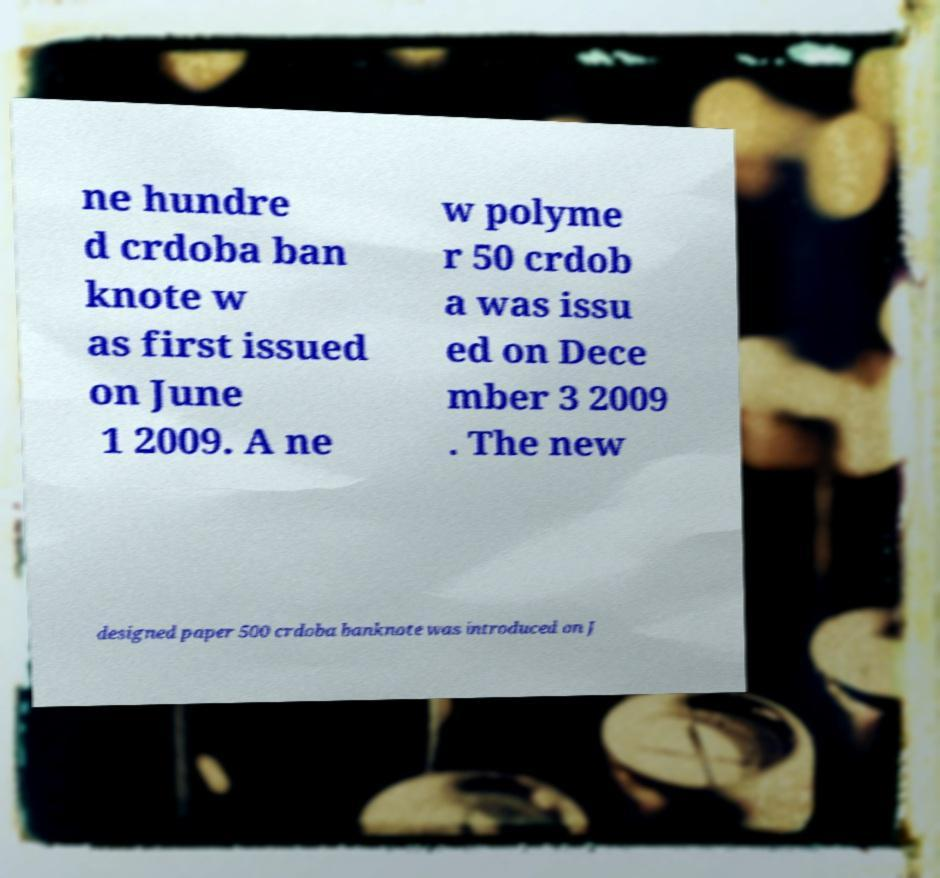Could you extract and type out the text from this image? ne hundre d crdoba ban knote w as first issued on June 1 2009. A ne w polyme r 50 crdob a was issu ed on Dece mber 3 2009 . The new designed paper 500 crdoba banknote was introduced on J 